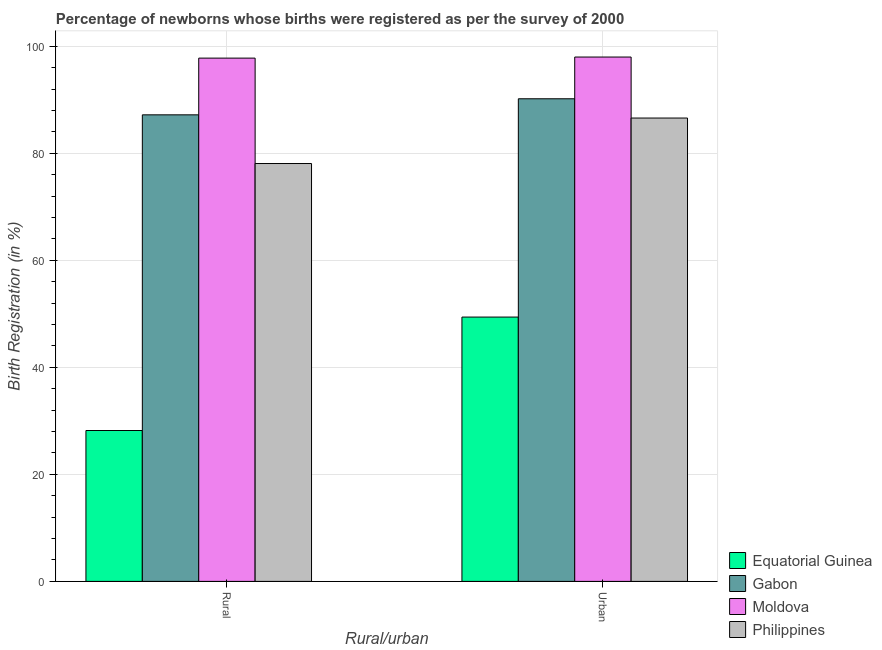How many bars are there on the 2nd tick from the left?
Offer a terse response. 4. How many bars are there on the 2nd tick from the right?
Provide a succinct answer. 4. What is the label of the 2nd group of bars from the left?
Give a very brief answer. Urban. What is the rural birth registration in Philippines?
Offer a terse response. 78.1. Across all countries, what is the maximum urban birth registration?
Your answer should be very brief. 98. Across all countries, what is the minimum rural birth registration?
Keep it short and to the point. 28.2. In which country was the urban birth registration maximum?
Provide a succinct answer. Moldova. In which country was the rural birth registration minimum?
Your answer should be compact. Equatorial Guinea. What is the total rural birth registration in the graph?
Your response must be concise. 291.3. What is the difference between the urban birth registration in Moldova and that in Philippines?
Your answer should be compact. 11.4. What is the difference between the urban birth registration in Gabon and the rural birth registration in Moldova?
Provide a short and direct response. -7.6. What is the average urban birth registration per country?
Make the answer very short. 81.05. What is the difference between the rural birth registration and urban birth registration in Moldova?
Provide a succinct answer. -0.2. What is the ratio of the urban birth registration in Gabon to that in Equatorial Guinea?
Your answer should be very brief. 1.83. Is the urban birth registration in Moldova less than that in Gabon?
Make the answer very short. No. In how many countries, is the rural birth registration greater than the average rural birth registration taken over all countries?
Make the answer very short. 3. What does the 4th bar from the left in Urban represents?
Your answer should be compact. Philippines. What does the 2nd bar from the right in Urban represents?
Provide a short and direct response. Moldova. How many bars are there?
Offer a very short reply. 8. Are all the bars in the graph horizontal?
Provide a succinct answer. No. How many countries are there in the graph?
Offer a very short reply. 4. What is the difference between two consecutive major ticks on the Y-axis?
Provide a succinct answer. 20. Where does the legend appear in the graph?
Your response must be concise. Bottom right. How many legend labels are there?
Keep it short and to the point. 4. What is the title of the graph?
Ensure brevity in your answer.  Percentage of newborns whose births were registered as per the survey of 2000. Does "Chad" appear as one of the legend labels in the graph?
Your answer should be very brief. No. What is the label or title of the X-axis?
Your response must be concise. Rural/urban. What is the label or title of the Y-axis?
Your answer should be compact. Birth Registration (in %). What is the Birth Registration (in %) in Equatorial Guinea in Rural?
Provide a succinct answer. 28.2. What is the Birth Registration (in %) in Gabon in Rural?
Ensure brevity in your answer.  87.2. What is the Birth Registration (in %) in Moldova in Rural?
Your answer should be very brief. 97.8. What is the Birth Registration (in %) in Philippines in Rural?
Provide a short and direct response. 78.1. What is the Birth Registration (in %) of Equatorial Guinea in Urban?
Give a very brief answer. 49.4. What is the Birth Registration (in %) in Gabon in Urban?
Offer a very short reply. 90.2. What is the Birth Registration (in %) in Moldova in Urban?
Provide a succinct answer. 98. What is the Birth Registration (in %) in Philippines in Urban?
Offer a terse response. 86.6. Across all Rural/urban, what is the maximum Birth Registration (in %) of Equatorial Guinea?
Provide a short and direct response. 49.4. Across all Rural/urban, what is the maximum Birth Registration (in %) of Gabon?
Make the answer very short. 90.2. Across all Rural/urban, what is the maximum Birth Registration (in %) of Philippines?
Provide a short and direct response. 86.6. Across all Rural/urban, what is the minimum Birth Registration (in %) in Equatorial Guinea?
Ensure brevity in your answer.  28.2. Across all Rural/urban, what is the minimum Birth Registration (in %) in Gabon?
Offer a very short reply. 87.2. Across all Rural/urban, what is the minimum Birth Registration (in %) of Moldova?
Provide a short and direct response. 97.8. Across all Rural/urban, what is the minimum Birth Registration (in %) of Philippines?
Ensure brevity in your answer.  78.1. What is the total Birth Registration (in %) in Equatorial Guinea in the graph?
Your response must be concise. 77.6. What is the total Birth Registration (in %) in Gabon in the graph?
Offer a terse response. 177.4. What is the total Birth Registration (in %) of Moldova in the graph?
Keep it short and to the point. 195.8. What is the total Birth Registration (in %) of Philippines in the graph?
Ensure brevity in your answer.  164.7. What is the difference between the Birth Registration (in %) of Equatorial Guinea in Rural and that in Urban?
Offer a terse response. -21.2. What is the difference between the Birth Registration (in %) in Gabon in Rural and that in Urban?
Provide a succinct answer. -3. What is the difference between the Birth Registration (in %) of Moldova in Rural and that in Urban?
Provide a succinct answer. -0.2. What is the difference between the Birth Registration (in %) in Philippines in Rural and that in Urban?
Keep it short and to the point. -8.5. What is the difference between the Birth Registration (in %) in Equatorial Guinea in Rural and the Birth Registration (in %) in Gabon in Urban?
Keep it short and to the point. -62. What is the difference between the Birth Registration (in %) of Equatorial Guinea in Rural and the Birth Registration (in %) of Moldova in Urban?
Provide a short and direct response. -69.8. What is the difference between the Birth Registration (in %) in Equatorial Guinea in Rural and the Birth Registration (in %) in Philippines in Urban?
Keep it short and to the point. -58.4. What is the difference between the Birth Registration (in %) in Gabon in Rural and the Birth Registration (in %) in Moldova in Urban?
Your response must be concise. -10.8. What is the difference between the Birth Registration (in %) of Gabon in Rural and the Birth Registration (in %) of Philippines in Urban?
Ensure brevity in your answer.  0.6. What is the difference between the Birth Registration (in %) of Moldova in Rural and the Birth Registration (in %) of Philippines in Urban?
Ensure brevity in your answer.  11.2. What is the average Birth Registration (in %) of Equatorial Guinea per Rural/urban?
Keep it short and to the point. 38.8. What is the average Birth Registration (in %) of Gabon per Rural/urban?
Make the answer very short. 88.7. What is the average Birth Registration (in %) in Moldova per Rural/urban?
Give a very brief answer. 97.9. What is the average Birth Registration (in %) of Philippines per Rural/urban?
Keep it short and to the point. 82.35. What is the difference between the Birth Registration (in %) in Equatorial Guinea and Birth Registration (in %) in Gabon in Rural?
Your response must be concise. -59. What is the difference between the Birth Registration (in %) in Equatorial Guinea and Birth Registration (in %) in Moldova in Rural?
Keep it short and to the point. -69.6. What is the difference between the Birth Registration (in %) of Equatorial Guinea and Birth Registration (in %) of Philippines in Rural?
Your answer should be very brief. -49.9. What is the difference between the Birth Registration (in %) of Gabon and Birth Registration (in %) of Moldova in Rural?
Make the answer very short. -10.6. What is the difference between the Birth Registration (in %) in Moldova and Birth Registration (in %) in Philippines in Rural?
Provide a succinct answer. 19.7. What is the difference between the Birth Registration (in %) in Equatorial Guinea and Birth Registration (in %) in Gabon in Urban?
Provide a succinct answer. -40.8. What is the difference between the Birth Registration (in %) of Equatorial Guinea and Birth Registration (in %) of Moldova in Urban?
Provide a short and direct response. -48.6. What is the difference between the Birth Registration (in %) of Equatorial Guinea and Birth Registration (in %) of Philippines in Urban?
Your answer should be very brief. -37.2. What is the ratio of the Birth Registration (in %) of Equatorial Guinea in Rural to that in Urban?
Your answer should be very brief. 0.57. What is the ratio of the Birth Registration (in %) in Gabon in Rural to that in Urban?
Provide a succinct answer. 0.97. What is the ratio of the Birth Registration (in %) in Moldova in Rural to that in Urban?
Keep it short and to the point. 1. What is the ratio of the Birth Registration (in %) in Philippines in Rural to that in Urban?
Ensure brevity in your answer.  0.9. What is the difference between the highest and the second highest Birth Registration (in %) in Equatorial Guinea?
Ensure brevity in your answer.  21.2. What is the difference between the highest and the lowest Birth Registration (in %) of Equatorial Guinea?
Your response must be concise. 21.2. What is the difference between the highest and the lowest Birth Registration (in %) of Gabon?
Ensure brevity in your answer.  3. What is the difference between the highest and the lowest Birth Registration (in %) in Philippines?
Give a very brief answer. 8.5. 